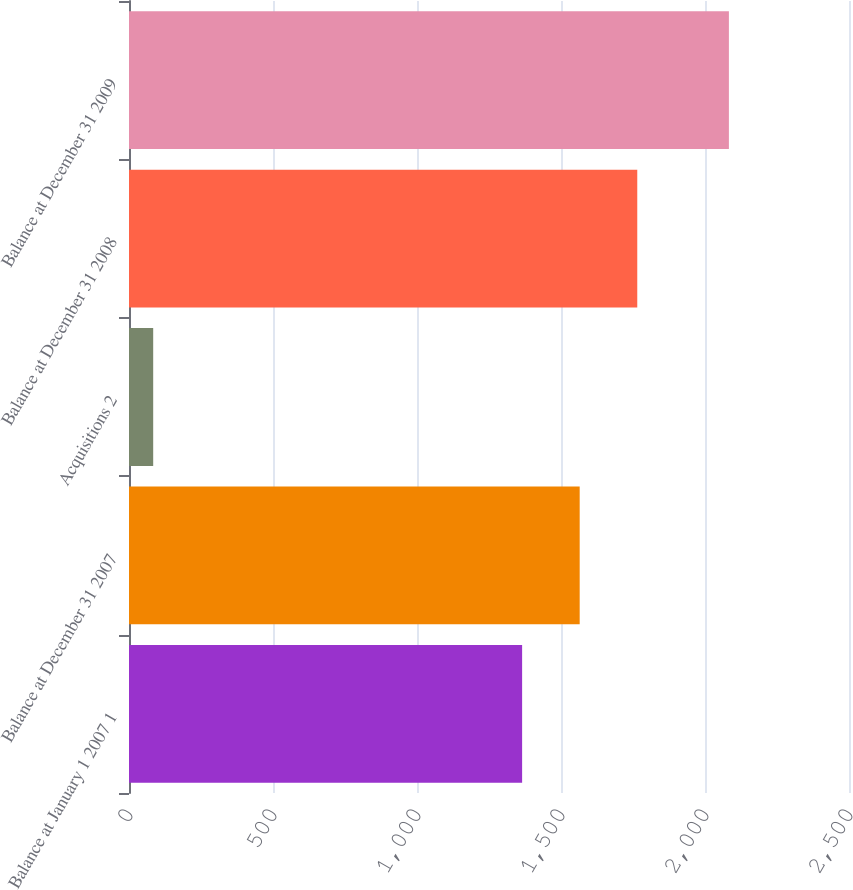Convert chart to OTSL. <chart><loc_0><loc_0><loc_500><loc_500><bar_chart><fcel>Balance at January 1 2007 1<fcel>Balance at December 31 2007<fcel>Acquisitions 2<fcel>Balance at December 31 2008<fcel>Balance at December 31 2009<nl><fcel>1365<fcel>1564.9<fcel>84<fcel>1764.8<fcel>2083<nl></chart> 